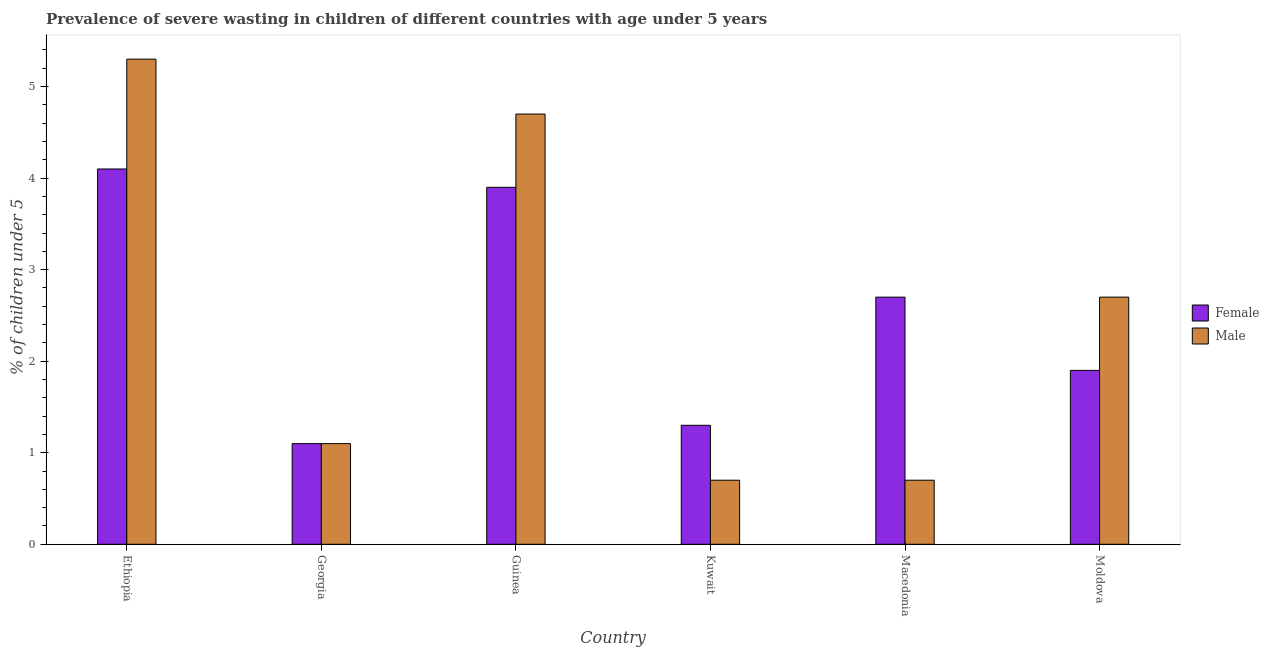How many different coloured bars are there?
Offer a very short reply. 2. Are the number of bars on each tick of the X-axis equal?
Make the answer very short. Yes. How many bars are there on the 3rd tick from the left?
Offer a very short reply. 2. How many bars are there on the 1st tick from the right?
Make the answer very short. 2. What is the label of the 3rd group of bars from the left?
Offer a very short reply. Guinea. In how many cases, is the number of bars for a given country not equal to the number of legend labels?
Give a very brief answer. 0. What is the percentage of undernourished male children in Kuwait?
Give a very brief answer. 0.7. Across all countries, what is the maximum percentage of undernourished female children?
Offer a terse response. 4.1. Across all countries, what is the minimum percentage of undernourished male children?
Provide a short and direct response. 0.7. In which country was the percentage of undernourished male children maximum?
Your answer should be very brief. Ethiopia. In which country was the percentage of undernourished female children minimum?
Give a very brief answer. Georgia. What is the total percentage of undernourished male children in the graph?
Offer a terse response. 15.2. What is the difference between the percentage of undernourished female children in Guinea and that in Moldova?
Your answer should be compact. 2. What is the difference between the percentage of undernourished female children in Macedonia and the percentage of undernourished male children in Kuwait?
Your answer should be very brief. 2. What is the average percentage of undernourished male children per country?
Offer a very short reply. 2.53. What is the ratio of the percentage of undernourished female children in Georgia to that in Guinea?
Make the answer very short. 0.28. What is the difference between the highest and the second highest percentage of undernourished male children?
Your answer should be compact. 0.6. What is the difference between the highest and the lowest percentage of undernourished male children?
Provide a short and direct response. 4.6. In how many countries, is the percentage of undernourished female children greater than the average percentage of undernourished female children taken over all countries?
Your response must be concise. 3. Is the sum of the percentage of undernourished female children in Guinea and Macedonia greater than the maximum percentage of undernourished male children across all countries?
Ensure brevity in your answer.  Yes. What does the 1st bar from the left in Guinea represents?
Your answer should be very brief. Female. How many bars are there?
Provide a succinct answer. 12. What is the difference between two consecutive major ticks on the Y-axis?
Keep it short and to the point. 1. Does the graph contain grids?
Keep it short and to the point. No. How many legend labels are there?
Provide a short and direct response. 2. How are the legend labels stacked?
Make the answer very short. Vertical. What is the title of the graph?
Offer a very short reply. Prevalence of severe wasting in children of different countries with age under 5 years. What is the label or title of the Y-axis?
Provide a succinct answer.  % of children under 5. What is the  % of children under 5 in Female in Ethiopia?
Provide a succinct answer. 4.1. What is the  % of children under 5 in Male in Ethiopia?
Provide a short and direct response. 5.3. What is the  % of children under 5 of Female in Georgia?
Provide a succinct answer. 1.1. What is the  % of children under 5 of Male in Georgia?
Provide a succinct answer. 1.1. What is the  % of children under 5 in Female in Guinea?
Your response must be concise. 3.9. What is the  % of children under 5 in Male in Guinea?
Make the answer very short. 4.7. What is the  % of children under 5 of Female in Kuwait?
Provide a short and direct response. 1.3. What is the  % of children under 5 in Male in Kuwait?
Make the answer very short. 0.7. What is the  % of children under 5 of Female in Macedonia?
Ensure brevity in your answer.  2.7. What is the  % of children under 5 in Male in Macedonia?
Your answer should be very brief. 0.7. What is the  % of children under 5 in Female in Moldova?
Provide a short and direct response. 1.9. What is the  % of children under 5 in Male in Moldova?
Keep it short and to the point. 2.7. Across all countries, what is the maximum  % of children under 5 in Female?
Give a very brief answer. 4.1. Across all countries, what is the maximum  % of children under 5 of Male?
Your answer should be very brief. 5.3. Across all countries, what is the minimum  % of children under 5 of Female?
Keep it short and to the point. 1.1. Across all countries, what is the minimum  % of children under 5 in Male?
Make the answer very short. 0.7. What is the total  % of children under 5 in Male in the graph?
Your answer should be very brief. 15.2. What is the difference between the  % of children under 5 of Male in Ethiopia and that in Georgia?
Ensure brevity in your answer.  4.2. What is the difference between the  % of children under 5 of Male in Ethiopia and that in Guinea?
Offer a terse response. 0.6. What is the difference between the  % of children under 5 in Female in Ethiopia and that in Macedonia?
Your response must be concise. 1.4. What is the difference between the  % of children under 5 of Male in Ethiopia and that in Macedonia?
Provide a short and direct response. 4.6. What is the difference between the  % of children under 5 of Female in Ethiopia and that in Moldova?
Offer a very short reply. 2.2. What is the difference between the  % of children under 5 of Female in Georgia and that in Guinea?
Provide a succinct answer. -2.8. What is the difference between the  % of children under 5 in Female in Georgia and that in Macedonia?
Your answer should be compact. -1.6. What is the difference between the  % of children under 5 of Male in Georgia and that in Macedonia?
Offer a very short reply. 0.4. What is the difference between the  % of children under 5 of Male in Georgia and that in Moldova?
Offer a terse response. -1.6. What is the difference between the  % of children under 5 of Female in Guinea and that in Kuwait?
Provide a short and direct response. 2.6. What is the difference between the  % of children under 5 in Male in Guinea and that in Kuwait?
Provide a short and direct response. 4. What is the difference between the  % of children under 5 in Female in Guinea and that in Macedonia?
Offer a very short reply. 1.2. What is the difference between the  % of children under 5 in Male in Guinea and that in Macedonia?
Give a very brief answer. 4. What is the difference between the  % of children under 5 of Female in Kuwait and that in Moldova?
Provide a short and direct response. -0.6. What is the difference between the  % of children under 5 in Male in Kuwait and that in Moldova?
Provide a succinct answer. -2. What is the difference between the  % of children under 5 of Female in Georgia and the  % of children under 5 of Male in Kuwait?
Offer a very short reply. 0.4. What is the difference between the  % of children under 5 of Female in Guinea and the  % of children under 5 of Male in Kuwait?
Offer a very short reply. 3.2. What is the difference between the  % of children under 5 of Female in Kuwait and the  % of children under 5 of Male in Moldova?
Give a very brief answer. -1.4. What is the difference between the  % of children under 5 in Female in Macedonia and the  % of children under 5 in Male in Moldova?
Offer a terse response. 0. What is the average  % of children under 5 of Female per country?
Provide a short and direct response. 2.5. What is the average  % of children under 5 of Male per country?
Ensure brevity in your answer.  2.53. What is the difference between the  % of children under 5 of Female and  % of children under 5 of Male in Georgia?
Ensure brevity in your answer.  0. What is the difference between the  % of children under 5 in Female and  % of children under 5 in Male in Guinea?
Provide a succinct answer. -0.8. What is the difference between the  % of children under 5 of Female and  % of children under 5 of Male in Moldova?
Your response must be concise. -0.8. What is the ratio of the  % of children under 5 of Female in Ethiopia to that in Georgia?
Provide a succinct answer. 3.73. What is the ratio of the  % of children under 5 in Male in Ethiopia to that in Georgia?
Provide a succinct answer. 4.82. What is the ratio of the  % of children under 5 of Female in Ethiopia to that in Guinea?
Offer a very short reply. 1.05. What is the ratio of the  % of children under 5 in Male in Ethiopia to that in Guinea?
Offer a terse response. 1.13. What is the ratio of the  % of children under 5 of Female in Ethiopia to that in Kuwait?
Your response must be concise. 3.15. What is the ratio of the  % of children under 5 in Male in Ethiopia to that in Kuwait?
Offer a terse response. 7.57. What is the ratio of the  % of children under 5 in Female in Ethiopia to that in Macedonia?
Your response must be concise. 1.52. What is the ratio of the  % of children under 5 in Male in Ethiopia to that in Macedonia?
Your response must be concise. 7.57. What is the ratio of the  % of children under 5 in Female in Ethiopia to that in Moldova?
Provide a succinct answer. 2.16. What is the ratio of the  % of children under 5 of Male in Ethiopia to that in Moldova?
Make the answer very short. 1.96. What is the ratio of the  % of children under 5 in Female in Georgia to that in Guinea?
Provide a short and direct response. 0.28. What is the ratio of the  % of children under 5 in Male in Georgia to that in Guinea?
Offer a terse response. 0.23. What is the ratio of the  % of children under 5 of Female in Georgia to that in Kuwait?
Your answer should be compact. 0.85. What is the ratio of the  % of children under 5 of Male in Georgia to that in Kuwait?
Provide a succinct answer. 1.57. What is the ratio of the  % of children under 5 of Female in Georgia to that in Macedonia?
Make the answer very short. 0.41. What is the ratio of the  % of children under 5 in Male in Georgia to that in Macedonia?
Make the answer very short. 1.57. What is the ratio of the  % of children under 5 of Female in Georgia to that in Moldova?
Your response must be concise. 0.58. What is the ratio of the  % of children under 5 of Male in Georgia to that in Moldova?
Provide a succinct answer. 0.41. What is the ratio of the  % of children under 5 in Male in Guinea to that in Kuwait?
Your answer should be compact. 6.71. What is the ratio of the  % of children under 5 of Female in Guinea to that in Macedonia?
Give a very brief answer. 1.44. What is the ratio of the  % of children under 5 of Male in Guinea to that in Macedonia?
Your answer should be compact. 6.71. What is the ratio of the  % of children under 5 in Female in Guinea to that in Moldova?
Your answer should be compact. 2.05. What is the ratio of the  % of children under 5 in Male in Guinea to that in Moldova?
Offer a terse response. 1.74. What is the ratio of the  % of children under 5 in Female in Kuwait to that in Macedonia?
Give a very brief answer. 0.48. What is the ratio of the  % of children under 5 in Male in Kuwait to that in Macedonia?
Give a very brief answer. 1. What is the ratio of the  % of children under 5 of Female in Kuwait to that in Moldova?
Provide a short and direct response. 0.68. What is the ratio of the  % of children under 5 in Male in Kuwait to that in Moldova?
Your answer should be very brief. 0.26. What is the ratio of the  % of children under 5 of Female in Macedonia to that in Moldova?
Make the answer very short. 1.42. What is the ratio of the  % of children under 5 in Male in Macedonia to that in Moldova?
Your answer should be very brief. 0.26. What is the difference between the highest and the second highest  % of children under 5 of Female?
Keep it short and to the point. 0.2. What is the difference between the highest and the second highest  % of children under 5 in Male?
Your answer should be very brief. 0.6. 